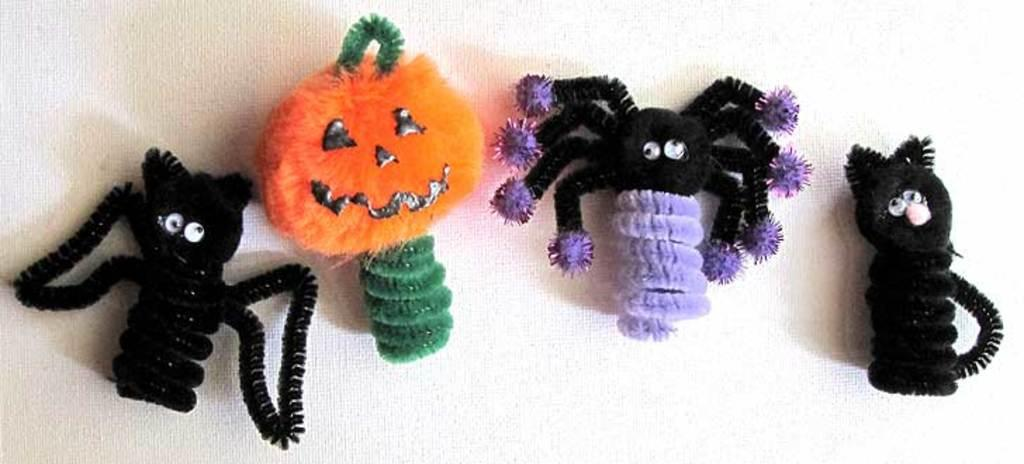What type of objects can be seen in the image? There are toys in the image. What songs are being sung by the toys in the image? There are no songs being sung by the toys in the image, as the provided fact only mentions that there are toys present. 